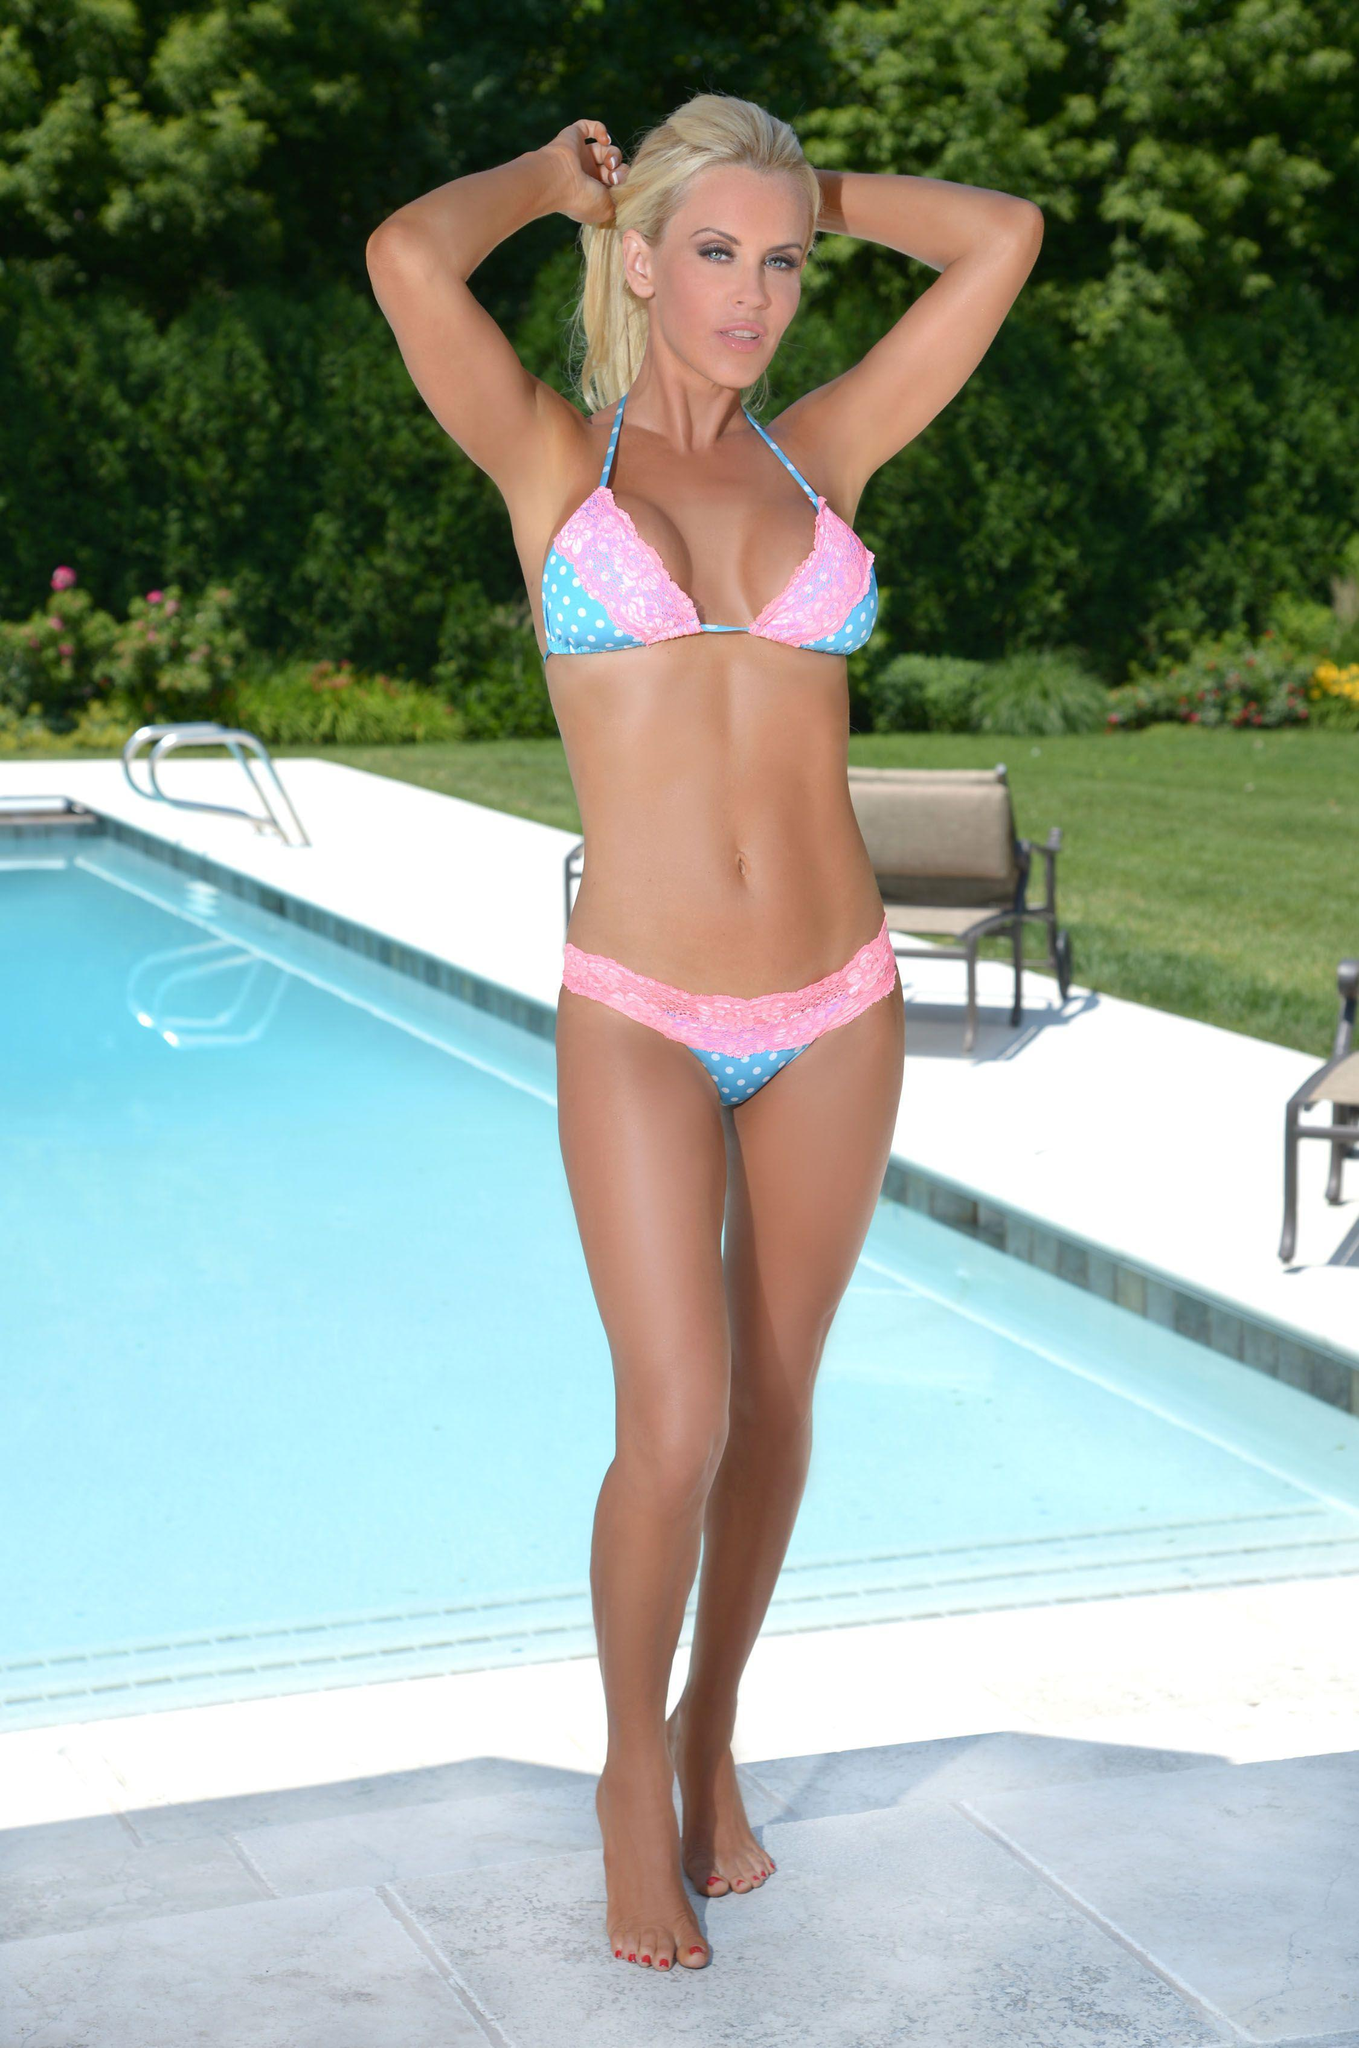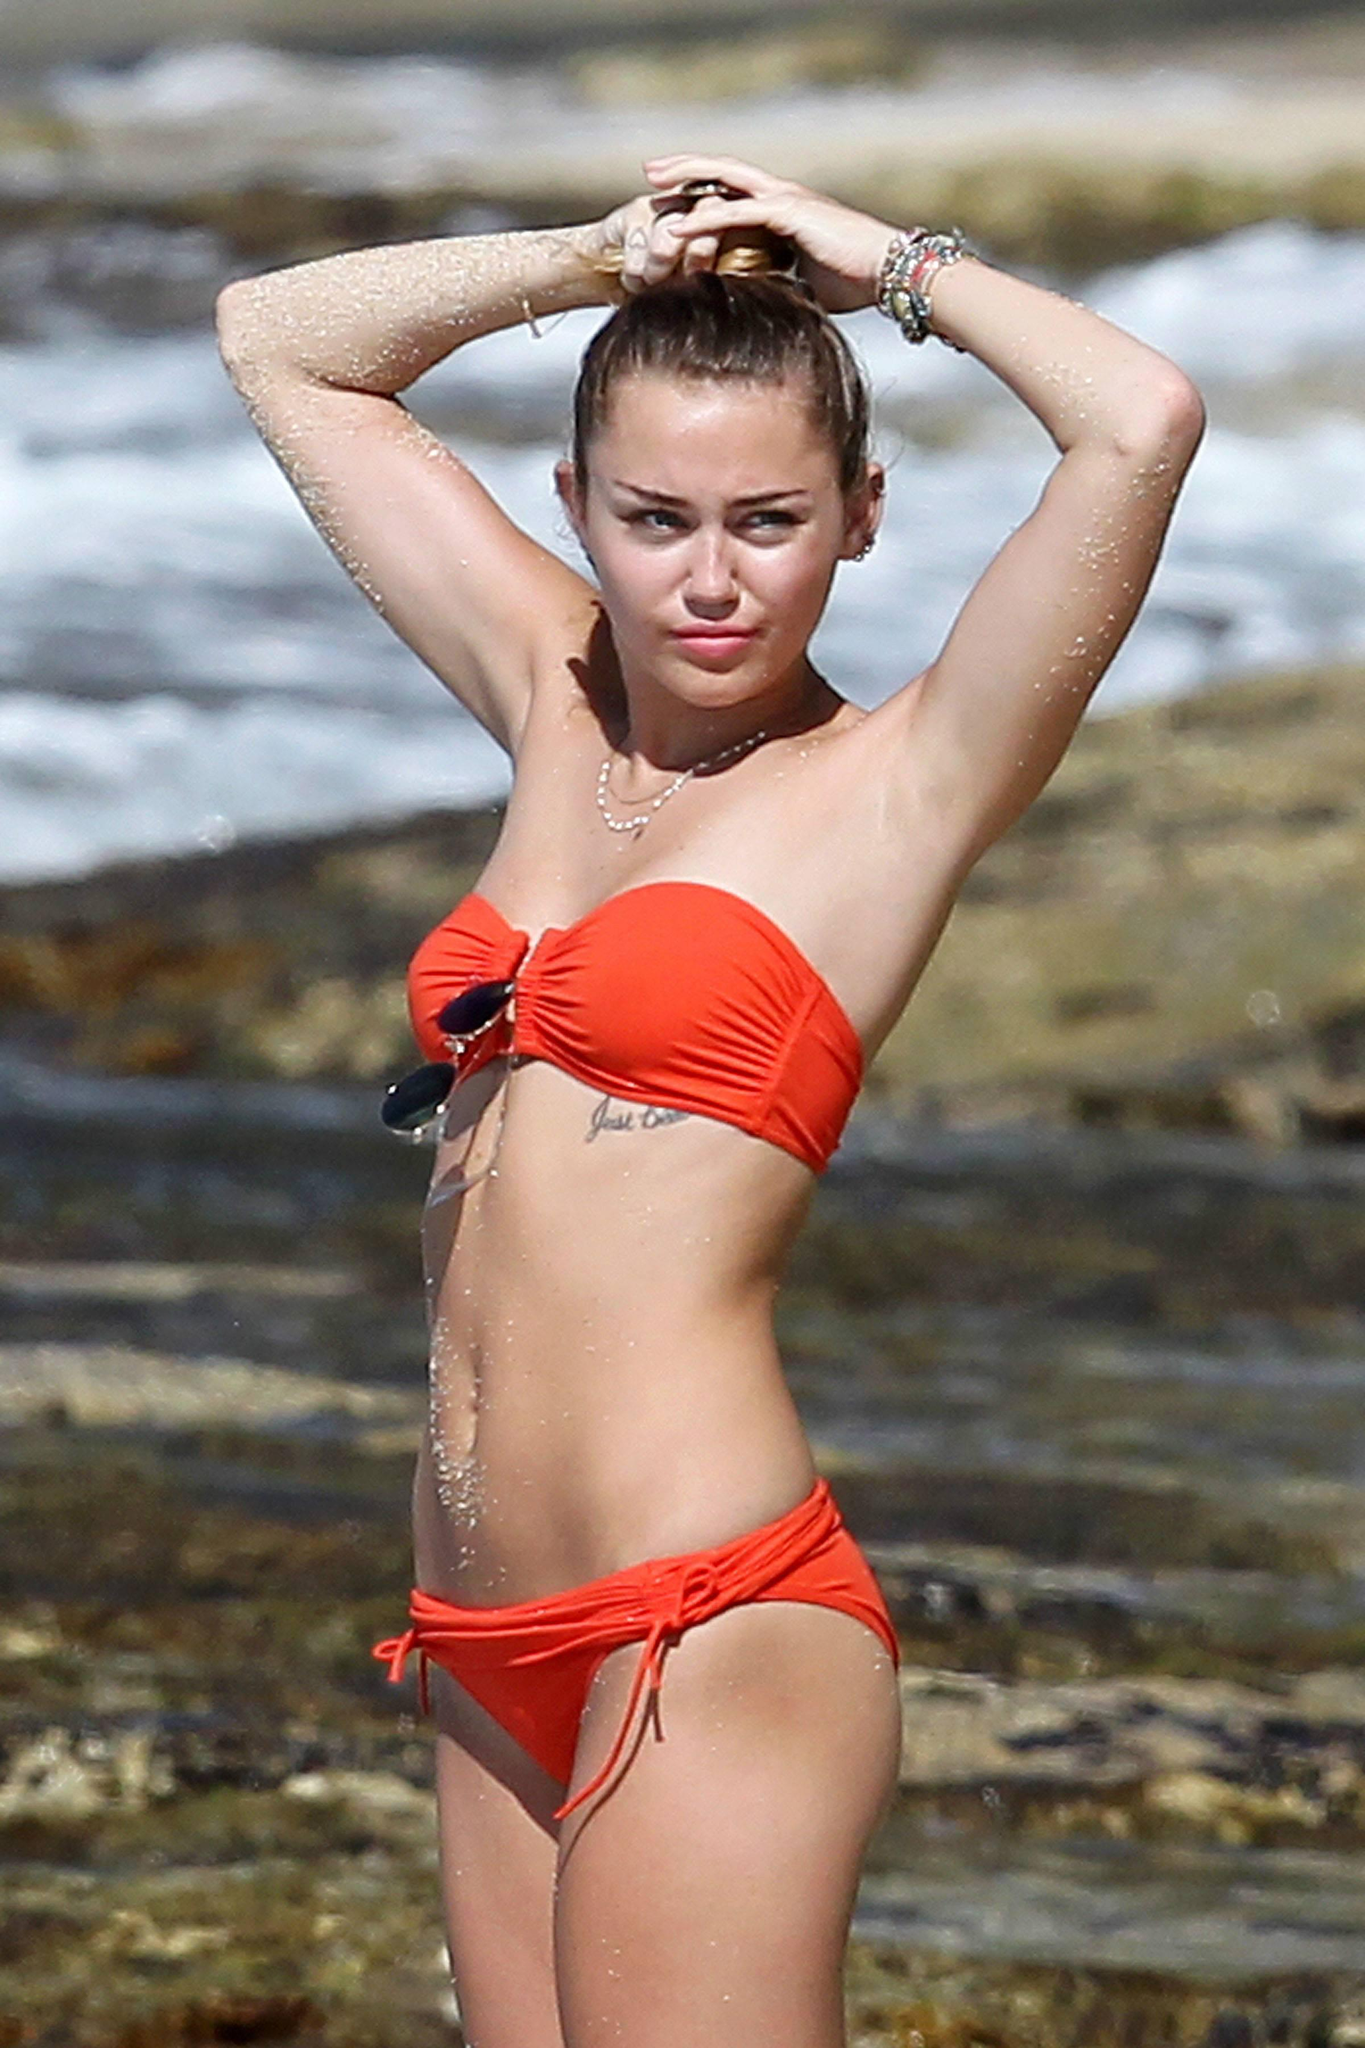The first image is the image on the left, the second image is the image on the right. Analyze the images presented: Is the assertion "The female on the right image has her hair tied up." valid? Answer yes or no. Yes. The first image is the image on the left, the second image is the image on the right. Analyze the images presented: Is the assertion "One woman is standing in the water." valid? Answer yes or no. No. 